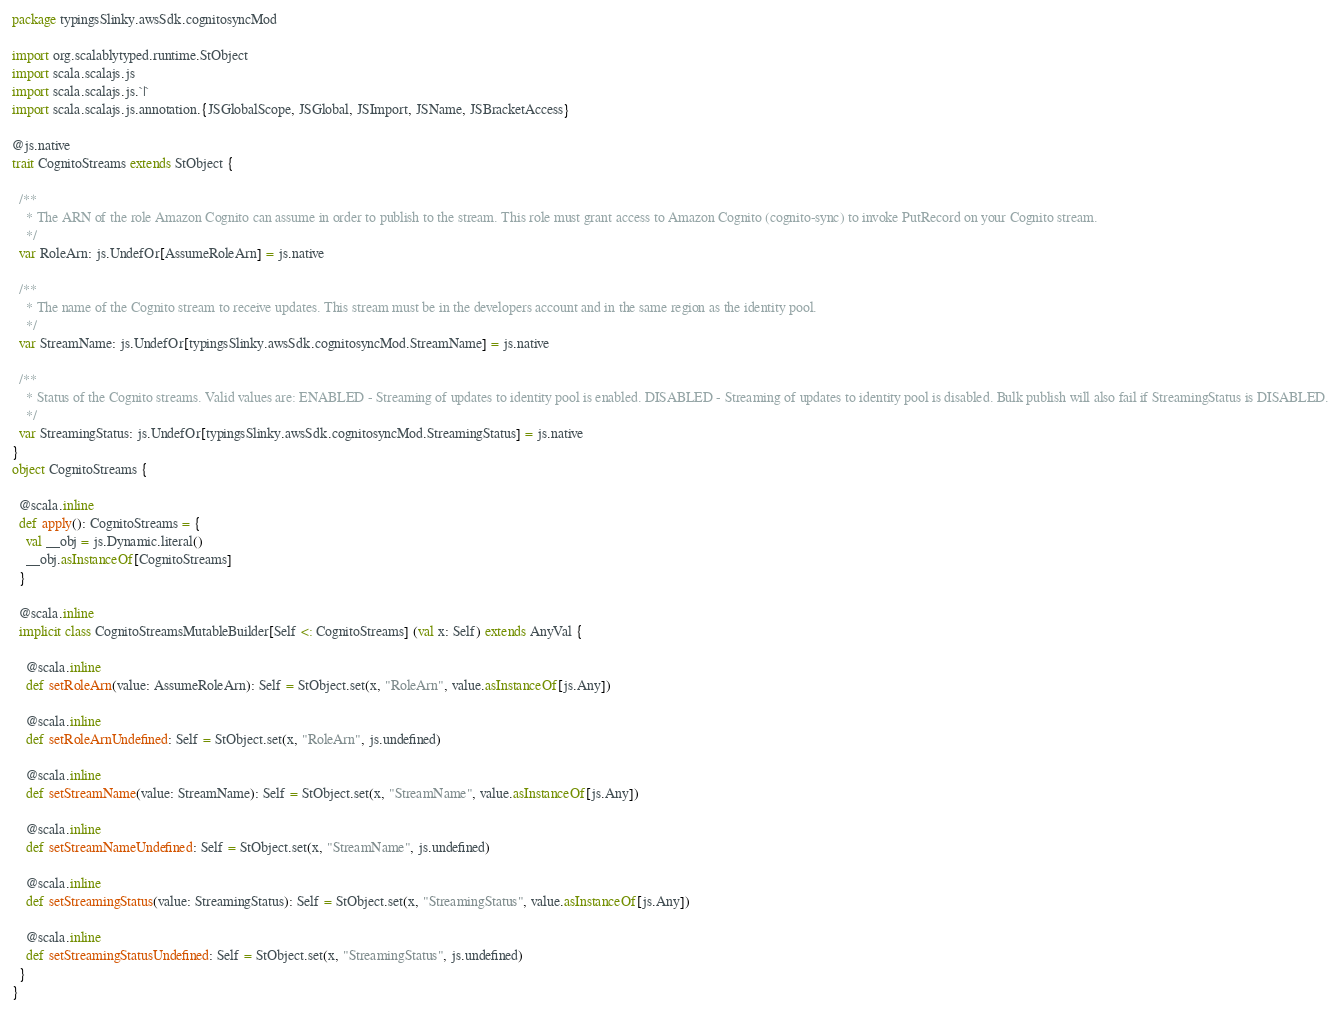<code> <loc_0><loc_0><loc_500><loc_500><_Scala_>package typingsSlinky.awsSdk.cognitosyncMod

import org.scalablytyped.runtime.StObject
import scala.scalajs.js
import scala.scalajs.js.`|`
import scala.scalajs.js.annotation.{JSGlobalScope, JSGlobal, JSImport, JSName, JSBracketAccess}

@js.native
trait CognitoStreams extends StObject {
  
  /**
    * The ARN of the role Amazon Cognito can assume in order to publish to the stream. This role must grant access to Amazon Cognito (cognito-sync) to invoke PutRecord on your Cognito stream.
    */
  var RoleArn: js.UndefOr[AssumeRoleArn] = js.native
  
  /**
    * The name of the Cognito stream to receive updates. This stream must be in the developers account and in the same region as the identity pool.
    */
  var StreamName: js.UndefOr[typingsSlinky.awsSdk.cognitosyncMod.StreamName] = js.native
  
  /**
    * Status of the Cognito streams. Valid values are: ENABLED - Streaming of updates to identity pool is enabled. DISABLED - Streaming of updates to identity pool is disabled. Bulk publish will also fail if StreamingStatus is DISABLED.
    */
  var StreamingStatus: js.UndefOr[typingsSlinky.awsSdk.cognitosyncMod.StreamingStatus] = js.native
}
object CognitoStreams {
  
  @scala.inline
  def apply(): CognitoStreams = {
    val __obj = js.Dynamic.literal()
    __obj.asInstanceOf[CognitoStreams]
  }
  
  @scala.inline
  implicit class CognitoStreamsMutableBuilder[Self <: CognitoStreams] (val x: Self) extends AnyVal {
    
    @scala.inline
    def setRoleArn(value: AssumeRoleArn): Self = StObject.set(x, "RoleArn", value.asInstanceOf[js.Any])
    
    @scala.inline
    def setRoleArnUndefined: Self = StObject.set(x, "RoleArn", js.undefined)
    
    @scala.inline
    def setStreamName(value: StreamName): Self = StObject.set(x, "StreamName", value.asInstanceOf[js.Any])
    
    @scala.inline
    def setStreamNameUndefined: Self = StObject.set(x, "StreamName", js.undefined)
    
    @scala.inline
    def setStreamingStatus(value: StreamingStatus): Self = StObject.set(x, "StreamingStatus", value.asInstanceOf[js.Any])
    
    @scala.inline
    def setStreamingStatusUndefined: Self = StObject.set(x, "StreamingStatus", js.undefined)
  }
}
</code> 